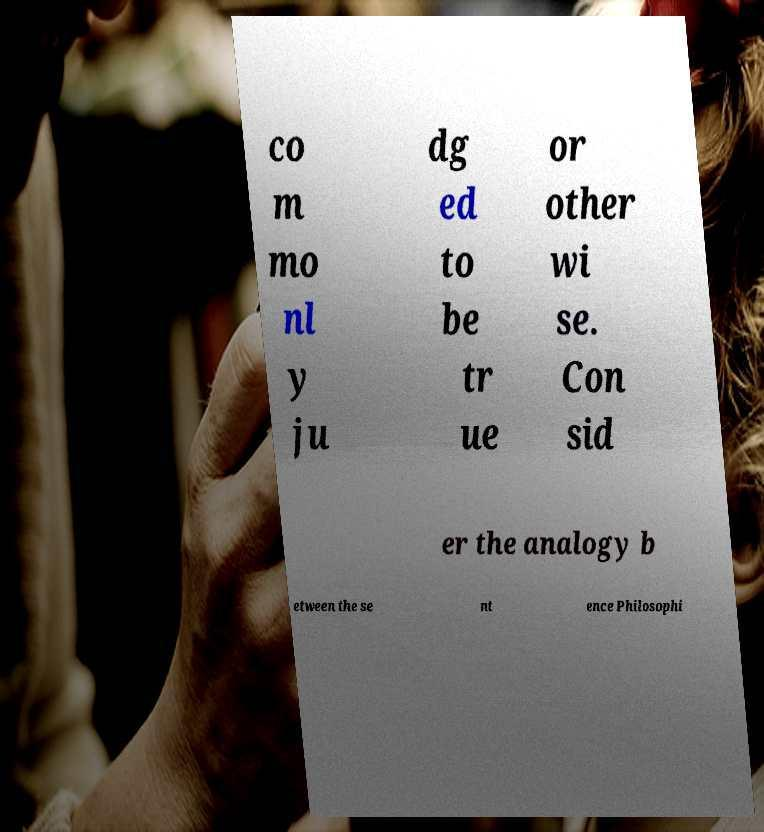Please identify and transcribe the text found in this image. co m mo nl y ju dg ed to be tr ue or other wi se. Con sid er the analogy b etween the se nt ence Philosophi 